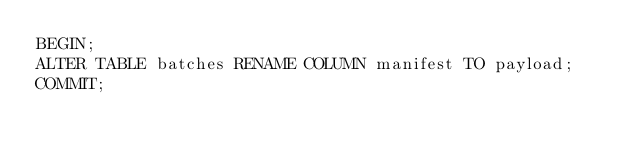Convert code to text. <code><loc_0><loc_0><loc_500><loc_500><_SQL_>BEGIN;
ALTER TABLE batches RENAME COLUMN manifest TO payload;
COMMIT;</code> 